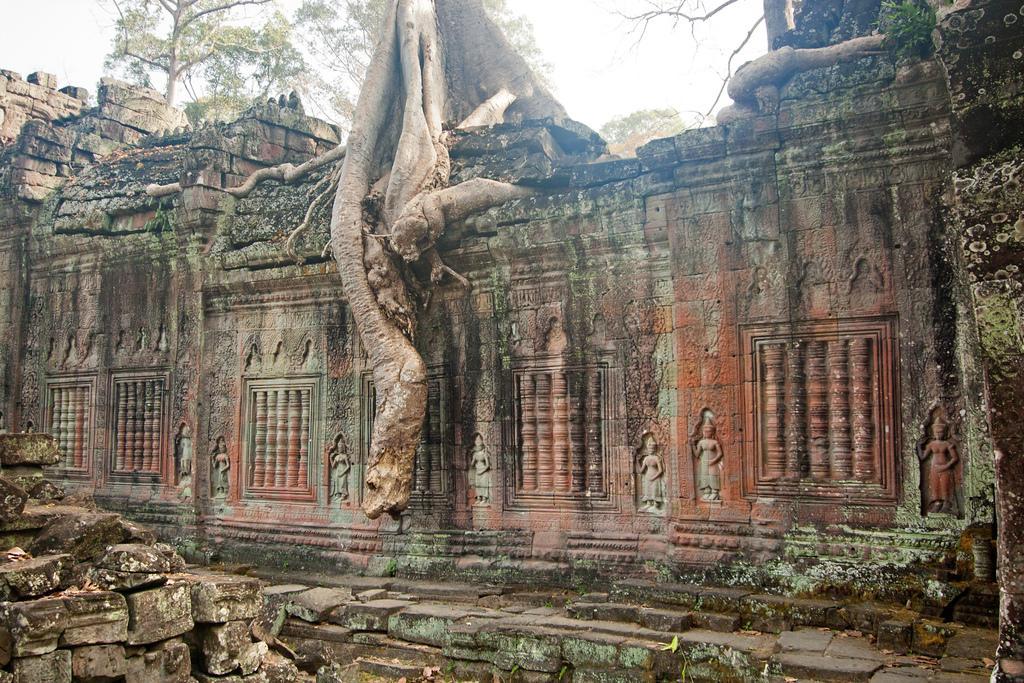Can you describe this image briefly? In this image we can see a structure which looks like a temple and we can see some sculptures on the wall. There are some trees and at the top we can see the sky. 